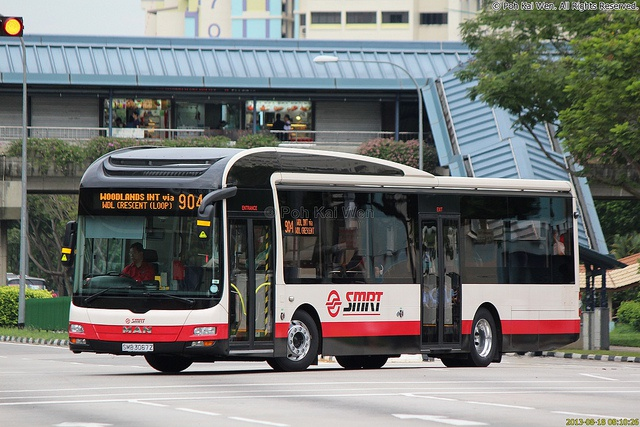Describe the objects in this image and their specific colors. I can see bus in lightgray, black, gray, and brown tones, people in lightgray, black, maroon, gray, and olive tones, traffic light in lightgray, black, gold, and maroon tones, people in lightgray, black, and gray tones, and people in lightgray, gray, black, and maroon tones in this image. 